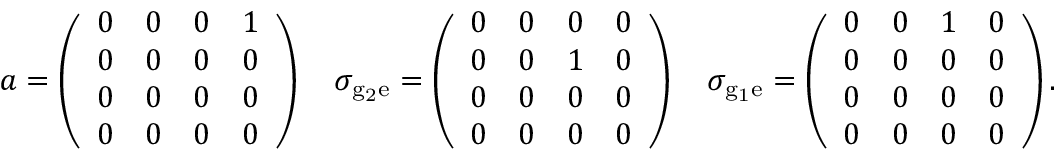Convert formula to latex. <formula><loc_0><loc_0><loc_500><loc_500>a = \left ( \begin{array} { l l l l } { 0 } & { 0 } & { 0 } & { 1 } \\ { 0 } & { 0 } & { 0 } & { 0 } \\ { 0 } & { 0 } & { 0 } & { 0 } \\ { 0 } & { 0 } & { 0 } & { 0 } \end{array} \right ) \quad \sigma _ { { g } _ { 2 } \mathrm { e } } = \left ( \begin{array} { l l l l } { 0 } & { 0 } & { 0 } & { 0 } \\ { 0 } & { 0 } & { 1 } & { 0 } \\ { 0 } & { 0 } & { 0 } & { 0 } \\ { 0 } & { 0 } & { 0 } & { 0 } \end{array} \right ) \quad \sigma _ { { g } _ { 1 } \mathrm { e } } = \left ( \begin{array} { l l l l } { 0 } & { 0 } & { 1 } & { 0 } \\ { 0 } & { 0 } & { 0 } & { 0 } \\ { 0 } & { 0 } & { 0 } & { 0 } \\ { 0 } & { 0 } & { 0 } & { 0 } \end{array} \right ) .</formula> 